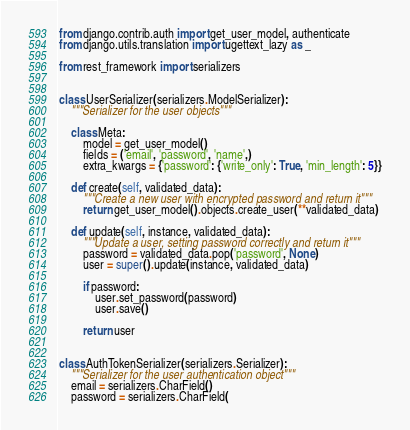Convert code to text. <code><loc_0><loc_0><loc_500><loc_500><_Python_>from django.contrib.auth import get_user_model, authenticate
from django.utils.translation import ugettext_lazy as _

from rest_framework import serializers


class UserSerializer(serializers.ModelSerializer):
    """Serializer for the user objects"""

    class Meta:
        model = get_user_model()
        fields = ('email', 'password', 'name',)
        extra_kwargs = {'password': {'write_only': True, 'min_length': 5}}

    def create(self, validated_data):
        """Create a new user with encrypted password and return it"""
        return get_user_model().objects.create_user(**validated_data)

    def update(self, instance, validated_data):
        """Update a user, setting password correctly and return it"""
        password = validated_data.pop('password', None)
        user = super().update(instance, validated_data)

        if password:
            user.set_password(password)
            user.save()

        return user


class AuthTokenSerializer(serializers.Serializer):
    """Serializer for the user authentication object"""
    email = serializers.CharField()
    password = serializers.CharField(</code> 